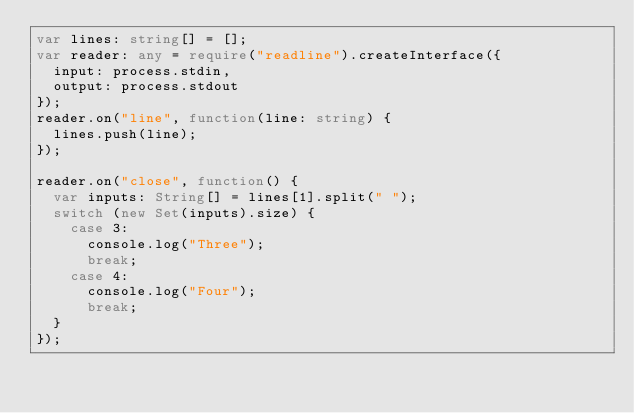Convert code to text. <code><loc_0><loc_0><loc_500><loc_500><_TypeScript_>var lines: string[] = [];
var reader: any = require("readline").createInterface({
  input: process.stdin,
  output: process.stdout
});
reader.on("line", function(line: string) {
  lines.push(line);
});

reader.on("close", function() {
  var inputs: String[] = lines[1].split(" ");
  switch (new Set(inputs).size) {
    case 3:
      console.log("Three");
      break;
    case 4:
      console.log("Four");
      break;
  }
});
</code> 